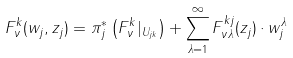Convert formula to latex. <formula><loc_0><loc_0><loc_500><loc_500>F ^ { k } _ { \nu } ( w _ { j } , z _ { j } ) = \pi _ { j } ^ { * } \left ( F ^ { k } _ { \nu } | _ { U _ { j k } } \right ) + \sum _ { \lambda = 1 } ^ { \infty } F ^ { k j } _ { \nu \lambda } ( z _ { j } ) \cdot w _ { j } ^ { \lambda }</formula> 